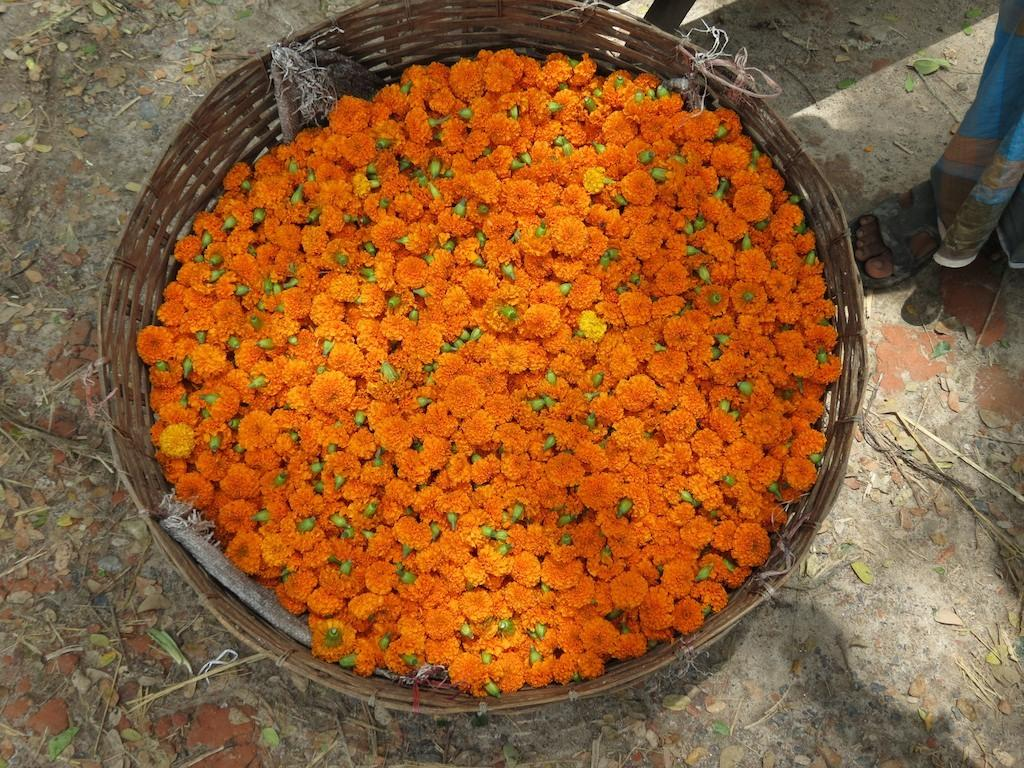What object can be seen in the image that is used for holding items? There is a basket in the image that is used for holding items. What is inside the basket? The basket contains flowers. What color are the flowers in the basket? The flowers are orange in color. What type of natural debris can be seen in the image? There are dry leaves in the image. What part of a person's body is visible in the image? A human leg is visible in the image. What type of footwear is present in the image? There is a sandal in the image. What type of berry is growing in space in the image? There is no berry growing in space in the image; the image features a basket of orange flowers, dry leaves, and a human leg. 